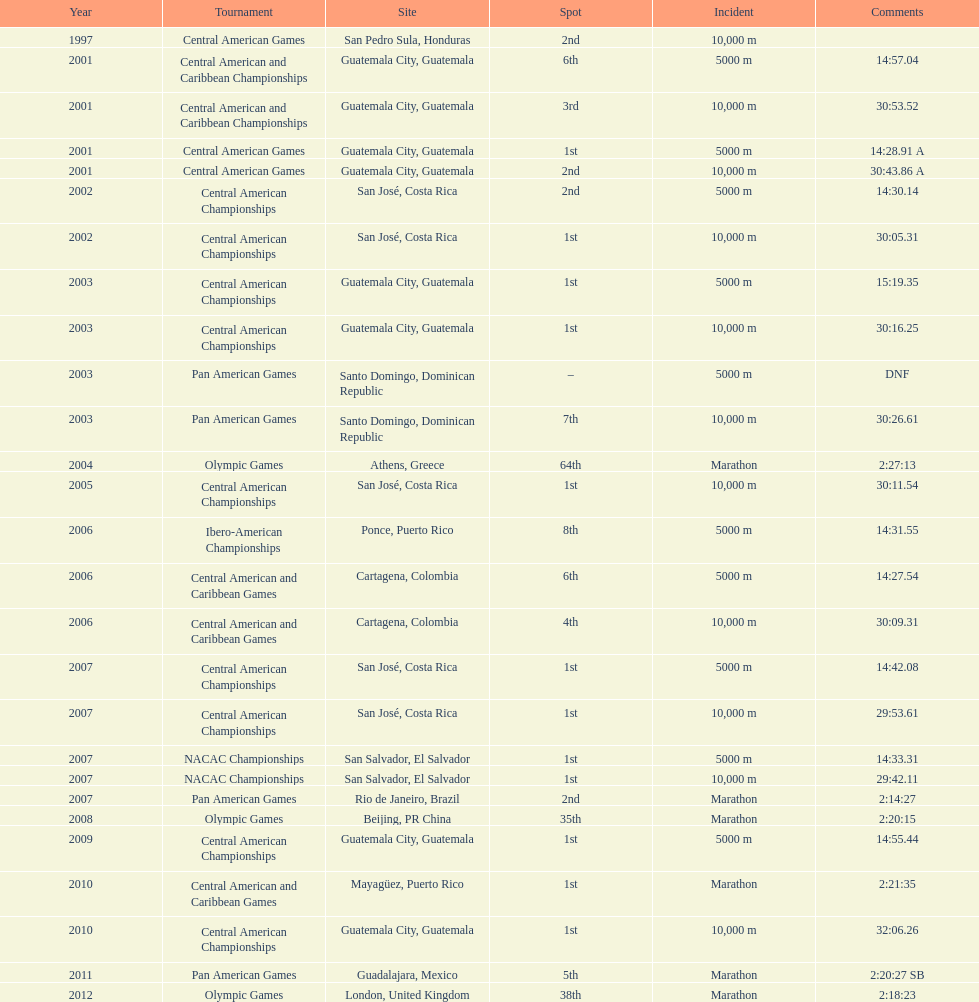Which of each game in 2007 was in the 2nd position? Pan American Games. 